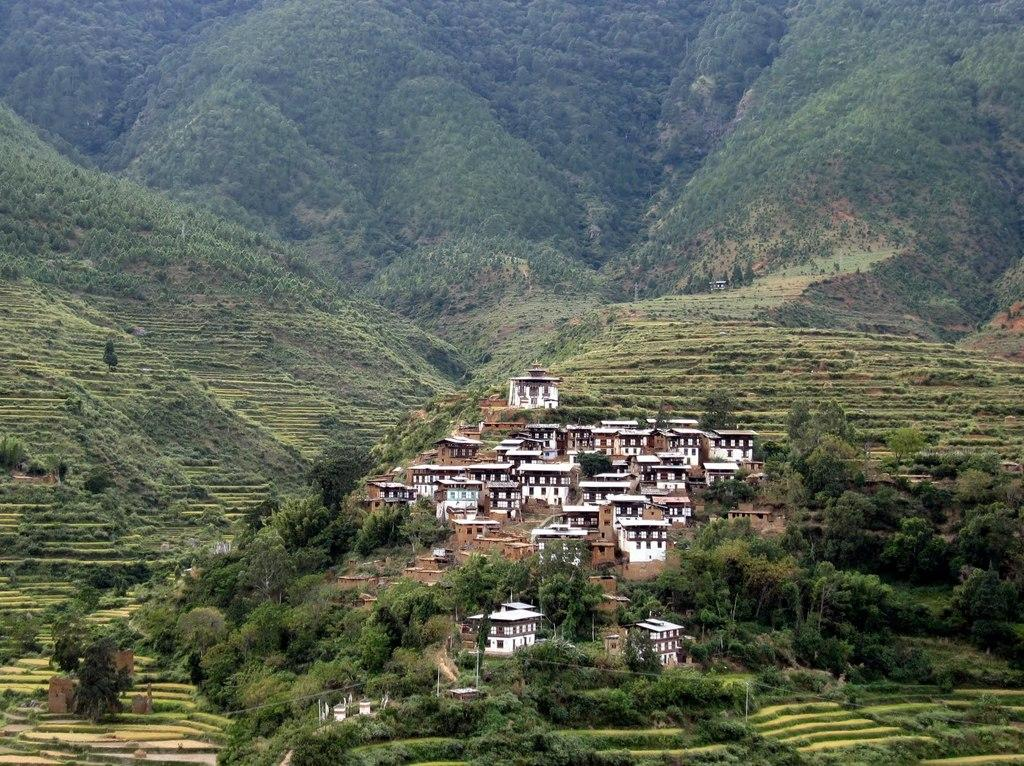What type of view is shown in the image? The image is an outside view. What can be seen in the middle of the image? There are buildings in the middle of the image. What type of vegetation is present in the image? There are many trees in the image. What geographical features can be seen at the top of the image? There are hills visible at the top of the image. What type of basin is visible in the image? There is no basin present in the image. Can you provide an example of a tree species found in the image? The provided facts do not specify the type of trees in the image, so it is impossible to provide an example of a tree species. 